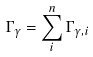Convert formula to latex. <formula><loc_0><loc_0><loc_500><loc_500>\Gamma _ { \gamma } = \sum _ { i } ^ { n } \Gamma _ { \gamma , i }</formula> 